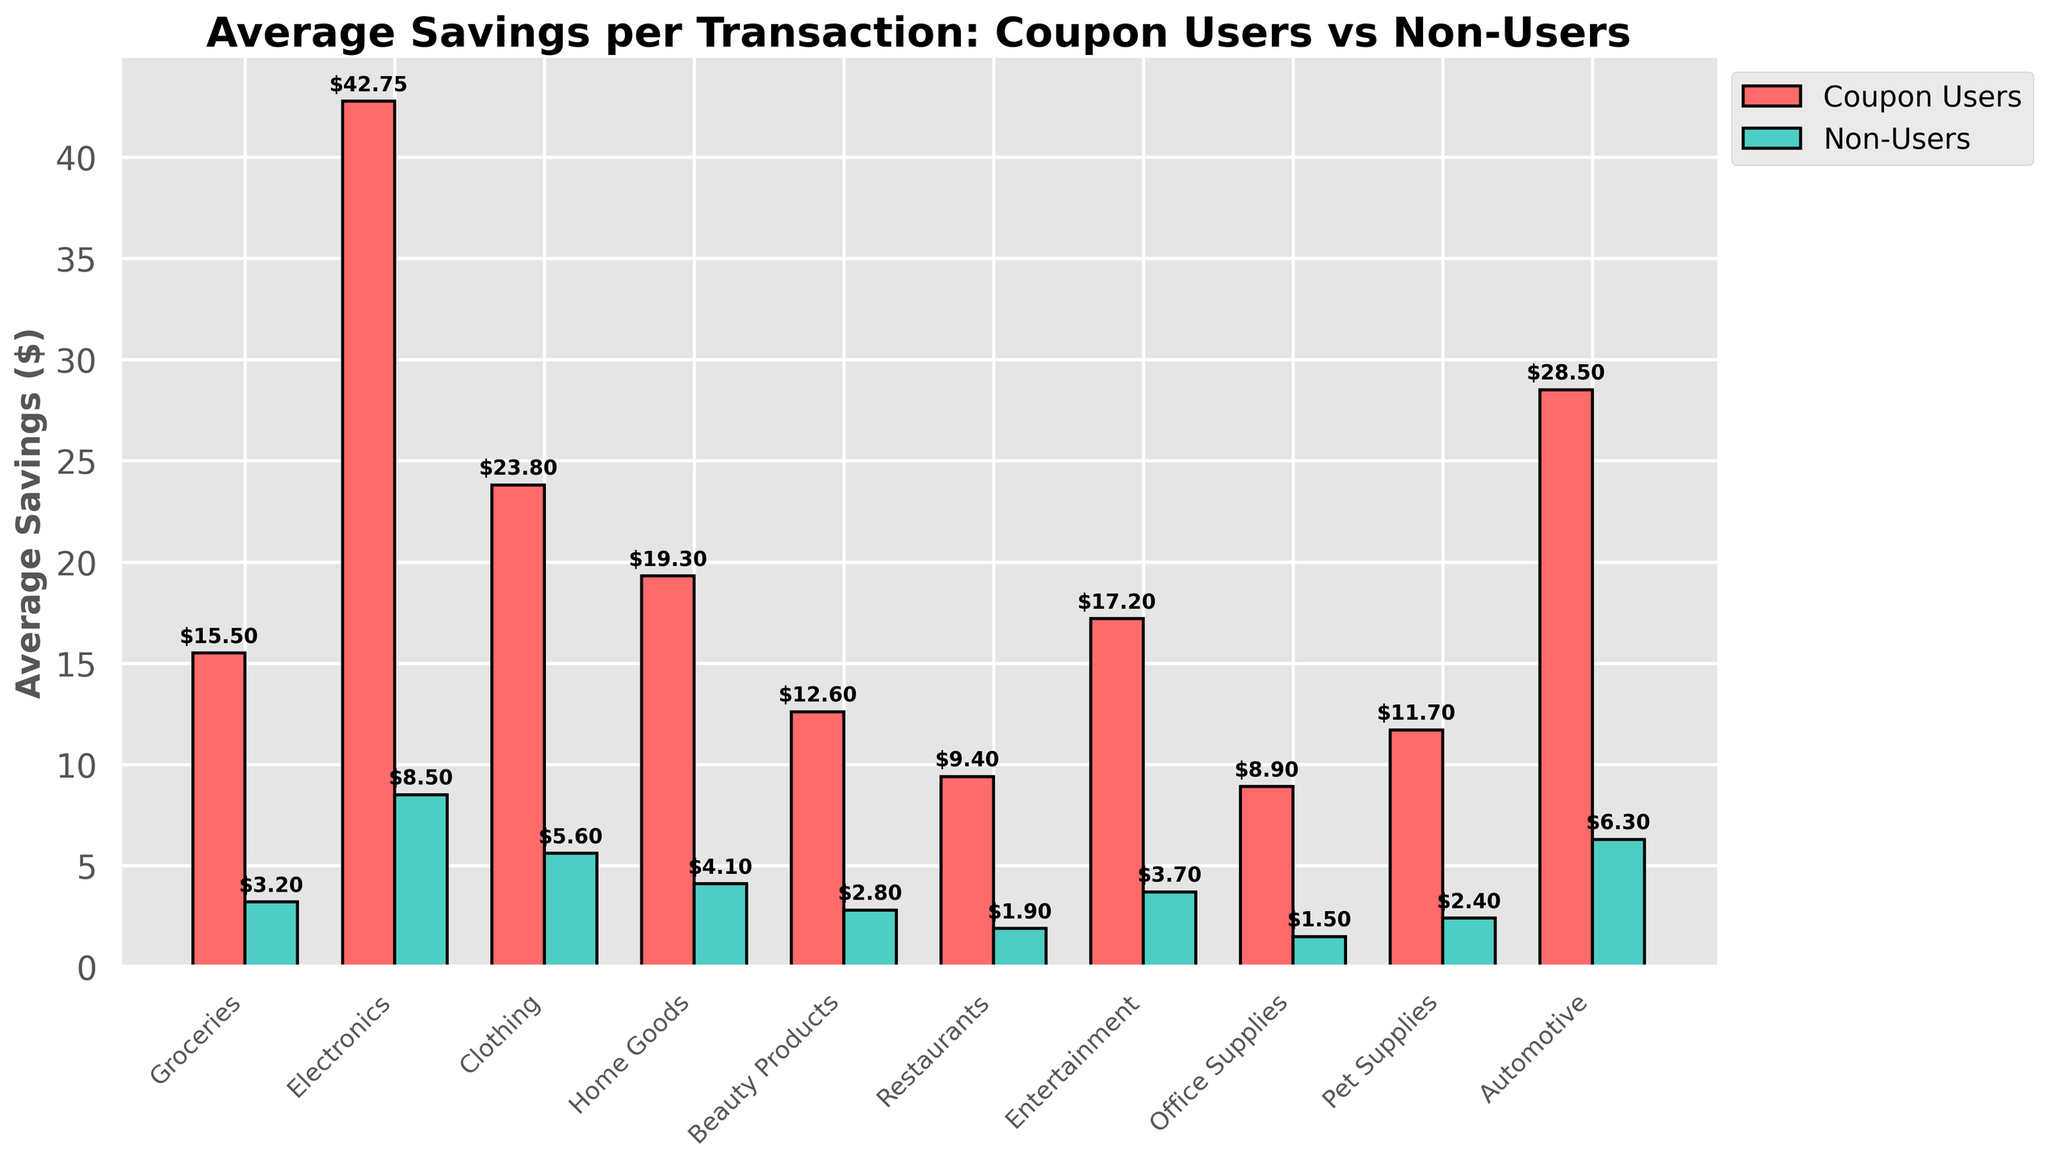What is the average savings for coupon users in the Electronics category? The bar representing coupon users for the Electronics category shows a height of $42.75.
Answer: $42.75 Which category shows the largest difference in average savings between coupon users and non-users? Calculate the difference for each category. The Electronics category has the largest difference, $42.75 (Coupon Users) - $8.50 (Non-Users) = $34.25.
Answer: Electronics What is the average savings for non-users in the Groceries category? The bar representing non-users for the Groceries category shows a height of $3.20.
Answer: $3.20 How much more do coupon users save on average in the Home Goods category compared to non-users? The bar representing coupon users in the Home Goods category has a height of $19.30, while non-users are at $4.10. The difference is $19.30 - $4.10 = $15.20.
Answer: $15.20 Which category has the lowest average savings for non-users? The shortest bar for non-users corresponds to the Office Supplies category with a height of $1.50.
Answer: Office Supplies Between the categories 'Pet Supplies' and 'Automotive', which one has higher average savings for coupon users? Compare the heights of the bars for coupon users: Pet Supplies ($11.70) and Automotive ($28.50). Automotive is higher.
Answer: Automotive Compare the average savings for non-users in Clothing and Beauty Products. Which category has higher savings? Clothing for non-users shows $5.60, and Beauty Products show $2.80. Clothing has higher savings.
Answer: Clothing What is the total average savings for coupon users across all categories? Sum the values for coupon users: $15.50 + $42.75 + $23.80 + $19.30 + $12.60 + $9.40 + $17.20 + $8.90 + $11.70 + $28.50 = $189.65.
Answer: $189.65 By how much do coupon users save more on average in the Entertainment category than non-users? Entertainment savings for coupon users is $17.20 and for non-users is $3.70. The difference is $17.20 - $3.70 = $13.50.
Answer: $13.50 What is the ratio of average savings of coupon users to non-users in the Restaurants category? Coupon users save $9.40 and non-users save $1.90 in Restaurants. The ratio is $9.40 / $1.90 = 4.95.
Answer: 4.95 